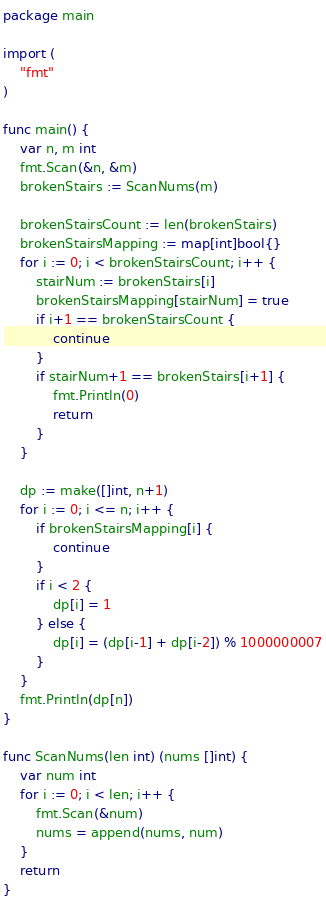Convert code to text. <code><loc_0><loc_0><loc_500><loc_500><_Go_>package main

import (
	"fmt"
)

func main() {
	var n, m int
	fmt.Scan(&n, &m)
	brokenStairs := ScanNums(m)

	brokenStairsCount := len(brokenStairs)
	brokenStairsMapping := map[int]bool{}
	for i := 0; i < brokenStairsCount; i++ {
		stairNum := brokenStairs[i]
		brokenStairsMapping[stairNum] = true
		if i+1 == brokenStairsCount {
			continue
		}
		if stairNum+1 == brokenStairs[i+1] {
			fmt.Println(0)
			return
		}
	}

	dp := make([]int, n+1)
	for i := 0; i <= n; i++ {
		if brokenStairsMapping[i] {
			continue
		}
		if i < 2 {
			dp[i] = 1
		} else {
			dp[i] = (dp[i-1] + dp[i-2]) % 1000000007
		}
	}
	fmt.Println(dp[n])
}

func ScanNums(len int) (nums []int) {
	var num int
	for i := 0; i < len; i++ {
		fmt.Scan(&num)
		nums = append(nums, num)
	}
	return
}
</code> 